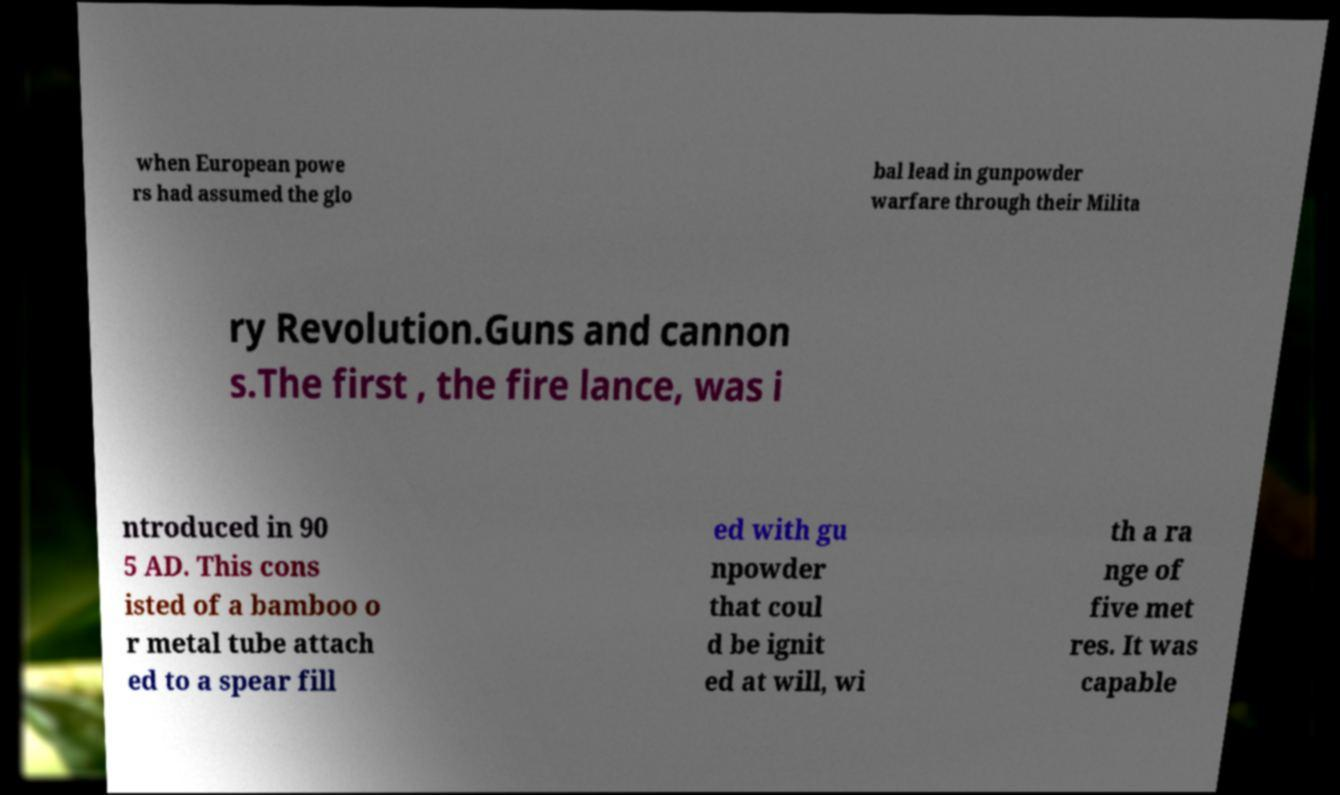I need the written content from this picture converted into text. Can you do that? when European powe rs had assumed the glo bal lead in gunpowder warfare through their Milita ry Revolution.Guns and cannon s.The first , the fire lance, was i ntroduced in 90 5 AD. This cons isted of a bamboo o r metal tube attach ed to a spear fill ed with gu npowder that coul d be ignit ed at will, wi th a ra nge of five met res. It was capable 